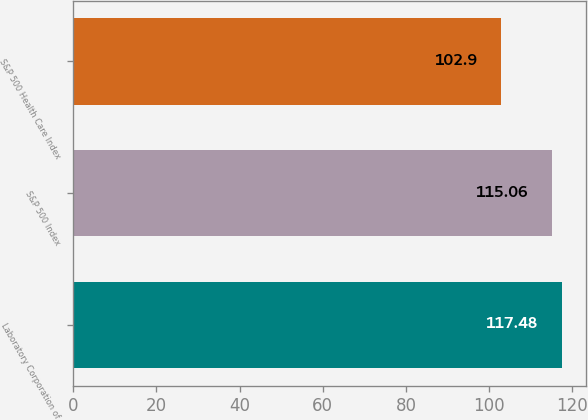<chart> <loc_0><loc_0><loc_500><loc_500><bar_chart><fcel>Laboratory Corporation of<fcel>S&P 500 Index<fcel>S&P 500 Health Care Index<nl><fcel>117.48<fcel>115.06<fcel>102.9<nl></chart> 